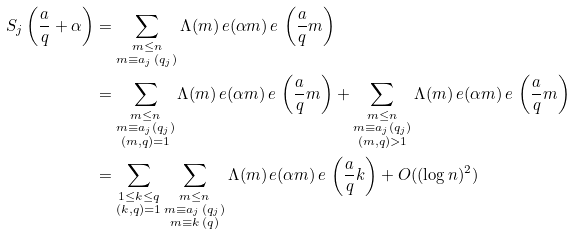Convert formula to latex. <formula><loc_0><loc_0><loc_500><loc_500>S _ { j } \left ( \frac { a } { q } + \alpha \right ) & = \sum _ { \substack { m \leq n \\ m \equiv a _ { j } \, ( q _ { j } ) } } \Lambda ( m ) \, e ( \alpha m ) \, e \, \left ( \frac { a } { q } m \right ) \\ & = \sum _ { \substack { m \leq n \\ m \equiv a _ { j } ( q _ { j } ) \\ ( m , q ) = 1 } } \Lambda ( m ) \, e ( \alpha m ) \, e \, \left ( \frac { a } { q } m \right ) + \sum _ { \substack { m \leq n \\ m \equiv a _ { j } ( q _ { j } ) \\ ( m , q ) > 1 } } \Lambda ( m ) \, e ( \alpha m ) \, e \, \left ( \frac { a } { q } m \right ) \\ & = \sum _ { \substack { 1 \leq k \leq q \\ ( k , q ) = 1 } } \sum _ { \substack { m \leq n \\ m \equiv a _ { j } \, ( q _ { j } ) \\ m \equiv k \, ( q ) } } \Lambda ( m ) \, e ( \alpha m ) \, e \, \left ( \frac { a } { q } k \right ) + O ( ( \log n ) ^ { 2 } )</formula> 